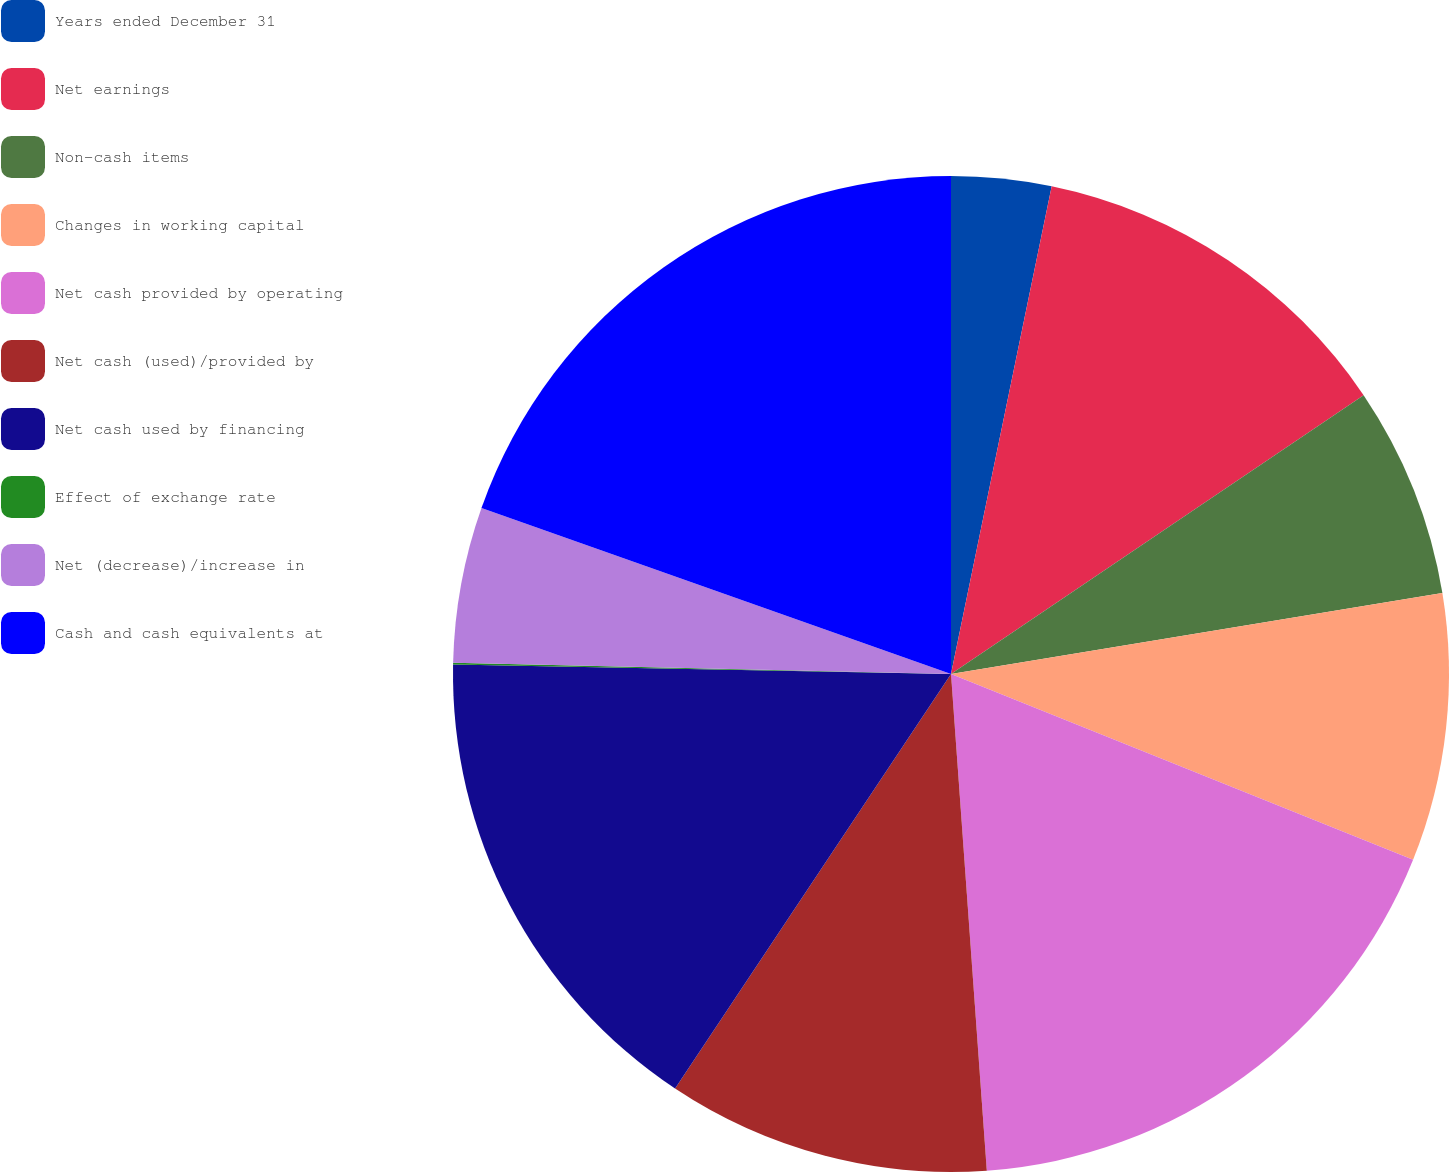Convert chart to OTSL. <chart><loc_0><loc_0><loc_500><loc_500><pie_chart><fcel>Years ended December 31<fcel>Net earnings<fcel>Non-cash items<fcel>Changes in working capital<fcel>Net cash provided by operating<fcel>Net cash (used)/provided by<fcel>Net cash used by financing<fcel>Effect of exchange rate<fcel>Net (decrease)/increase in<fcel>Cash and cash equivalents at<nl><fcel>3.24%<fcel>12.3%<fcel>6.86%<fcel>8.68%<fcel>17.77%<fcel>10.49%<fcel>15.96%<fcel>0.05%<fcel>5.05%<fcel>19.59%<nl></chart> 